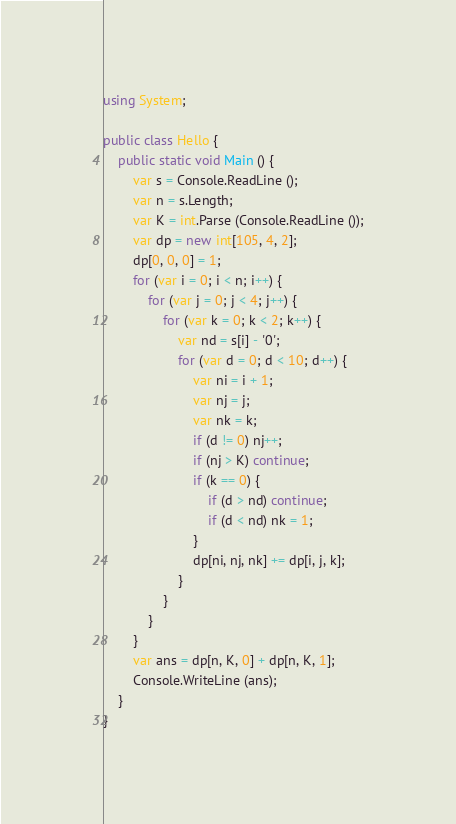<code> <loc_0><loc_0><loc_500><loc_500><_C#_>using System;

public class Hello {
    public static void Main () {
        var s = Console.ReadLine ();
        var n = s.Length;
        var K = int.Parse (Console.ReadLine ());
        var dp = new int[105, 4, 2];
        dp[0, 0, 0] = 1;
        for (var i = 0; i < n; i++) {
            for (var j = 0; j < 4; j++) {
                for (var k = 0; k < 2; k++) {
                    var nd = s[i] - '0';
                    for (var d = 0; d < 10; d++) {
                        var ni = i + 1;
                        var nj = j;
                        var nk = k;
                        if (d != 0) nj++;
                        if (nj > K) continue;
                        if (k == 0) {
                            if (d > nd) continue;
                            if (d < nd) nk = 1;
                        }
                        dp[ni, nj, nk] += dp[i, j, k];
                    }
                }
            }
        }
        var ans = dp[n, K, 0] + dp[n, K, 1];
        Console.WriteLine (ans);
    }
}</code> 